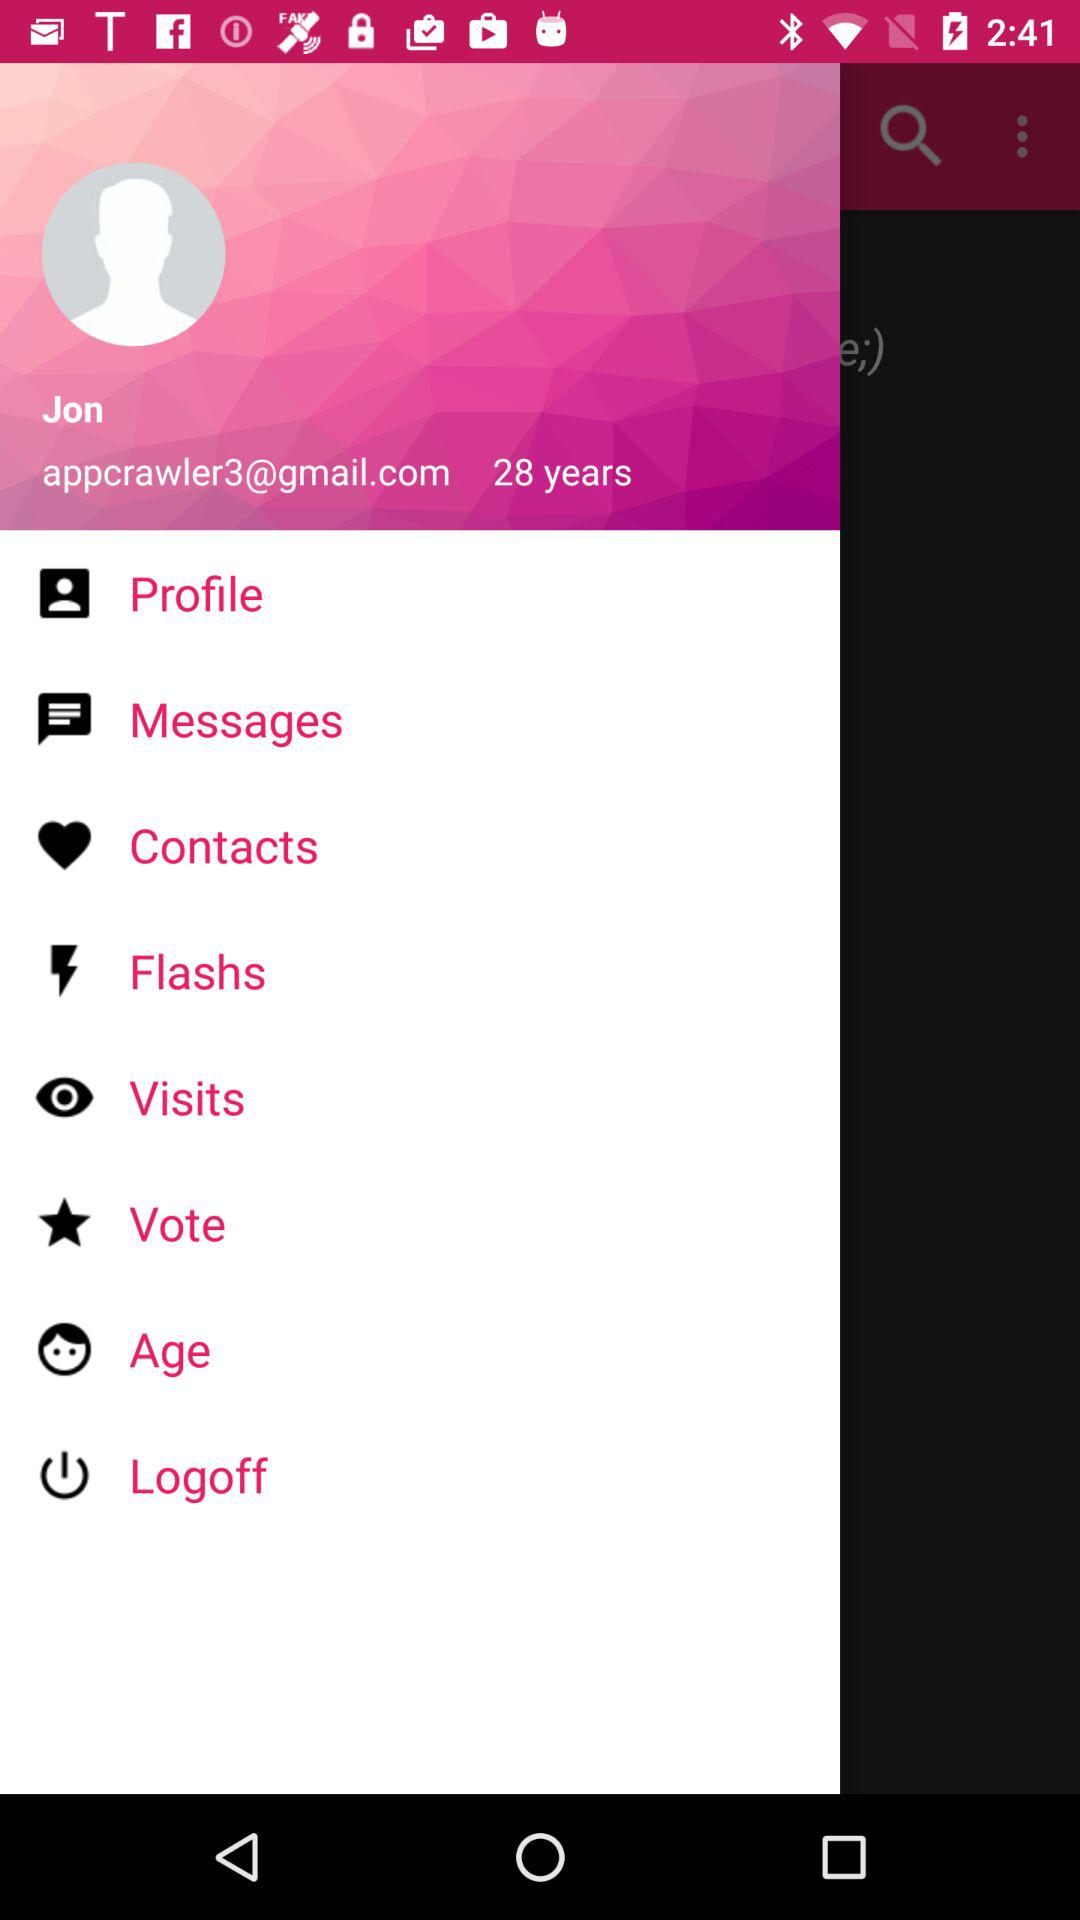What is the given age? The given age is 28 years. 